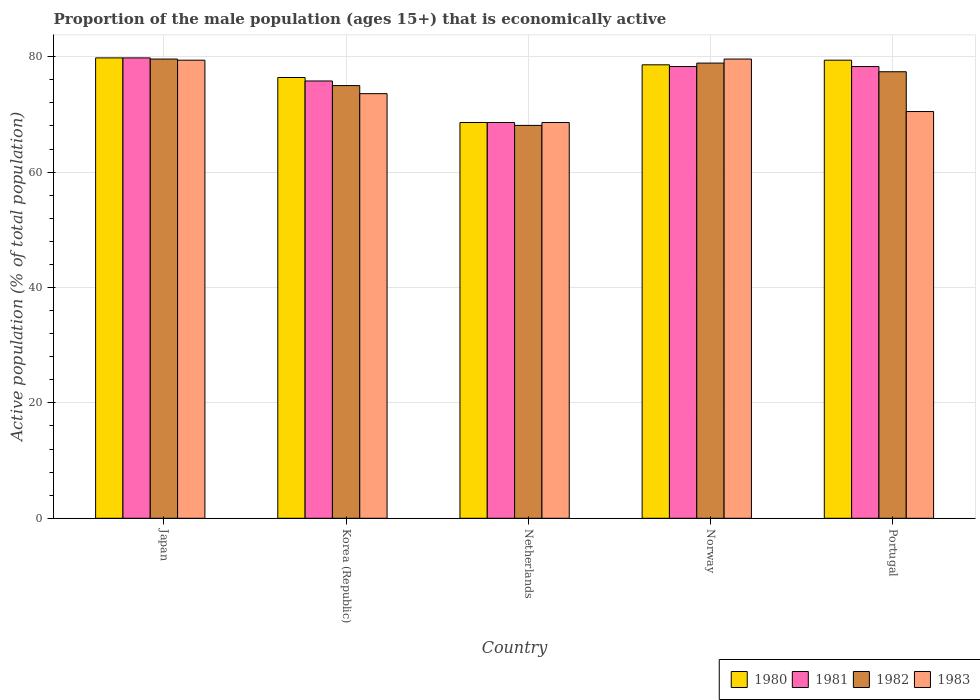How many different coloured bars are there?
Offer a very short reply. 4. Are the number of bars per tick equal to the number of legend labels?
Your answer should be compact. Yes. Are the number of bars on each tick of the X-axis equal?
Provide a short and direct response. Yes. How many bars are there on the 5th tick from the left?
Make the answer very short. 4. In how many cases, is the number of bars for a given country not equal to the number of legend labels?
Make the answer very short. 0. What is the proportion of the male population that is economically active in 1981 in Netherlands?
Your answer should be compact. 68.6. Across all countries, what is the maximum proportion of the male population that is economically active in 1983?
Your response must be concise. 79.6. Across all countries, what is the minimum proportion of the male population that is economically active in 1983?
Your answer should be very brief. 68.6. What is the total proportion of the male population that is economically active in 1983 in the graph?
Ensure brevity in your answer.  371.7. What is the difference between the proportion of the male population that is economically active in 1980 in Japan and that in Korea (Republic)?
Your answer should be very brief. 3.4. What is the difference between the proportion of the male population that is economically active in 1981 in Netherlands and the proportion of the male population that is economically active in 1983 in Portugal?
Provide a short and direct response. -1.9. What is the average proportion of the male population that is economically active in 1981 per country?
Your response must be concise. 76.16. What is the difference between the proportion of the male population that is economically active of/in 1983 and proportion of the male population that is economically active of/in 1981 in Portugal?
Your response must be concise. -7.8. In how many countries, is the proportion of the male population that is economically active in 1983 greater than 76 %?
Give a very brief answer. 2. What is the ratio of the proportion of the male population that is economically active in 1983 in Japan to that in Netherlands?
Give a very brief answer. 1.16. Is the proportion of the male population that is economically active in 1982 in Korea (Republic) less than that in Netherlands?
Make the answer very short. No. What is the difference between the highest and the second highest proportion of the male population that is economically active in 1980?
Make the answer very short. -0.8. What is the difference between the highest and the lowest proportion of the male population that is economically active in 1980?
Your answer should be very brief. 11.2. In how many countries, is the proportion of the male population that is economically active in 1981 greater than the average proportion of the male population that is economically active in 1981 taken over all countries?
Offer a terse response. 3. Is it the case that in every country, the sum of the proportion of the male population that is economically active in 1982 and proportion of the male population that is economically active in 1983 is greater than the sum of proportion of the male population that is economically active in 1980 and proportion of the male population that is economically active in 1981?
Offer a very short reply. No. What does the 4th bar from the right in Portugal represents?
Your answer should be compact. 1980. What is the difference between two consecutive major ticks on the Y-axis?
Make the answer very short. 20. Are the values on the major ticks of Y-axis written in scientific E-notation?
Keep it short and to the point. No. Does the graph contain any zero values?
Provide a short and direct response. No. Where does the legend appear in the graph?
Ensure brevity in your answer.  Bottom right. How many legend labels are there?
Make the answer very short. 4. What is the title of the graph?
Offer a terse response. Proportion of the male population (ages 15+) that is economically active. What is the label or title of the X-axis?
Make the answer very short. Country. What is the label or title of the Y-axis?
Give a very brief answer. Active population (% of total population). What is the Active population (% of total population) in 1980 in Japan?
Give a very brief answer. 79.8. What is the Active population (% of total population) in 1981 in Japan?
Your answer should be very brief. 79.8. What is the Active population (% of total population) of 1982 in Japan?
Your answer should be compact. 79.6. What is the Active population (% of total population) in 1983 in Japan?
Ensure brevity in your answer.  79.4. What is the Active population (% of total population) in 1980 in Korea (Republic)?
Your response must be concise. 76.4. What is the Active population (% of total population) of 1981 in Korea (Republic)?
Provide a succinct answer. 75.8. What is the Active population (% of total population) of 1983 in Korea (Republic)?
Offer a terse response. 73.6. What is the Active population (% of total population) of 1980 in Netherlands?
Provide a succinct answer. 68.6. What is the Active population (% of total population) in 1981 in Netherlands?
Your response must be concise. 68.6. What is the Active population (% of total population) in 1982 in Netherlands?
Provide a short and direct response. 68.1. What is the Active population (% of total population) in 1983 in Netherlands?
Your answer should be very brief. 68.6. What is the Active population (% of total population) of 1980 in Norway?
Make the answer very short. 78.6. What is the Active population (% of total population) in 1981 in Norway?
Offer a terse response. 78.3. What is the Active population (% of total population) in 1982 in Norway?
Ensure brevity in your answer.  78.9. What is the Active population (% of total population) of 1983 in Norway?
Ensure brevity in your answer.  79.6. What is the Active population (% of total population) in 1980 in Portugal?
Make the answer very short. 79.4. What is the Active population (% of total population) of 1981 in Portugal?
Your response must be concise. 78.3. What is the Active population (% of total population) of 1982 in Portugal?
Provide a succinct answer. 77.4. What is the Active population (% of total population) in 1983 in Portugal?
Provide a short and direct response. 70.5. Across all countries, what is the maximum Active population (% of total population) in 1980?
Offer a very short reply. 79.8. Across all countries, what is the maximum Active population (% of total population) in 1981?
Provide a succinct answer. 79.8. Across all countries, what is the maximum Active population (% of total population) in 1982?
Provide a short and direct response. 79.6. Across all countries, what is the maximum Active population (% of total population) of 1983?
Provide a short and direct response. 79.6. Across all countries, what is the minimum Active population (% of total population) of 1980?
Keep it short and to the point. 68.6. Across all countries, what is the minimum Active population (% of total population) in 1981?
Your response must be concise. 68.6. Across all countries, what is the minimum Active population (% of total population) of 1982?
Give a very brief answer. 68.1. Across all countries, what is the minimum Active population (% of total population) of 1983?
Your answer should be very brief. 68.6. What is the total Active population (% of total population) of 1980 in the graph?
Make the answer very short. 382.8. What is the total Active population (% of total population) in 1981 in the graph?
Offer a terse response. 380.8. What is the total Active population (% of total population) of 1982 in the graph?
Provide a succinct answer. 379. What is the total Active population (% of total population) in 1983 in the graph?
Make the answer very short. 371.7. What is the difference between the Active population (% of total population) of 1980 in Japan and that in Korea (Republic)?
Your answer should be very brief. 3.4. What is the difference between the Active population (% of total population) of 1981 in Japan and that in Korea (Republic)?
Your response must be concise. 4. What is the difference between the Active population (% of total population) in 1982 in Japan and that in Korea (Republic)?
Keep it short and to the point. 4.6. What is the difference between the Active population (% of total population) in 1983 in Japan and that in Korea (Republic)?
Offer a very short reply. 5.8. What is the difference between the Active population (% of total population) of 1980 in Japan and that in Netherlands?
Your answer should be very brief. 11.2. What is the difference between the Active population (% of total population) of 1982 in Japan and that in Netherlands?
Your answer should be very brief. 11.5. What is the difference between the Active population (% of total population) in 1983 in Japan and that in Netherlands?
Offer a terse response. 10.8. What is the difference between the Active population (% of total population) in 1980 in Japan and that in Norway?
Offer a very short reply. 1.2. What is the difference between the Active population (% of total population) of 1981 in Japan and that in Norway?
Keep it short and to the point. 1.5. What is the difference between the Active population (% of total population) in 1982 in Japan and that in Norway?
Your response must be concise. 0.7. What is the difference between the Active population (% of total population) of 1983 in Japan and that in Norway?
Make the answer very short. -0.2. What is the difference between the Active population (% of total population) of 1980 in Japan and that in Portugal?
Give a very brief answer. 0.4. What is the difference between the Active population (% of total population) in 1982 in Japan and that in Portugal?
Ensure brevity in your answer.  2.2. What is the difference between the Active population (% of total population) of 1983 in Japan and that in Portugal?
Offer a very short reply. 8.9. What is the difference between the Active population (% of total population) in 1982 in Korea (Republic) and that in Netherlands?
Keep it short and to the point. 6.9. What is the difference between the Active population (% of total population) in 1983 in Korea (Republic) and that in Netherlands?
Keep it short and to the point. 5. What is the difference between the Active population (% of total population) of 1982 in Korea (Republic) and that in Norway?
Keep it short and to the point. -3.9. What is the difference between the Active population (% of total population) in 1983 in Korea (Republic) and that in Norway?
Offer a very short reply. -6. What is the difference between the Active population (% of total population) in 1980 in Korea (Republic) and that in Portugal?
Offer a terse response. -3. What is the difference between the Active population (% of total population) in 1982 in Korea (Republic) and that in Portugal?
Your response must be concise. -2.4. What is the difference between the Active population (% of total population) of 1983 in Korea (Republic) and that in Portugal?
Ensure brevity in your answer.  3.1. What is the difference between the Active population (% of total population) of 1980 in Netherlands and that in Norway?
Provide a succinct answer. -10. What is the difference between the Active population (% of total population) in 1981 in Netherlands and that in Norway?
Your answer should be compact. -9.7. What is the difference between the Active population (% of total population) in 1983 in Netherlands and that in Norway?
Provide a short and direct response. -11. What is the difference between the Active population (% of total population) of 1981 in Netherlands and that in Portugal?
Offer a terse response. -9.7. What is the difference between the Active population (% of total population) of 1983 in Netherlands and that in Portugal?
Offer a very short reply. -1.9. What is the difference between the Active population (% of total population) of 1980 in Norway and that in Portugal?
Your response must be concise. -0.8. What is the difference between the Active population (% of total population) of 1982 in Norway and that in Portugal?
Keep it short and to the point. 1.5. What is the difference between the Active population (% of total population) in 1980 in Japan and the Active population (% of total population) in 1982 in Korea (Republic)?
Your response must be concise. 4.8. What is the difference between the Active population (% of total population) of 1981 in Japan and the Active population (% of total population) of 1982 in Korea (Republic)?
Make the answer very short. 4.8. What is the difference between the Active population (% of total population) in 1982 in Japan and the Active population (% of total population) in 1983 in Korea (Republic)?
Keep it short and to the point. 6. What is the difference between the Active population (% of total population) of 1980 in Japan and the Active population (% of total population) of 1983 in Netherlands?
Make the answer very short. 11.2. What is the difference between the Active population (% of total population) in 1981 in Japan and the Active population (% of total population) in 1983 in Netherlands?
Offer a very short reply. 11.2. What is the difference between the Active population (% of total population) in 1980 in Japan and the Active population (% of total population) in 1981 in Norway?
Ensure brevity in your answer.  1.5. What is the difference between the Active population (% of total population) of 1981 in Japan and the Active population (% of total population) of 1982 in Norway?
Ensure brevity in your answer.  0.9. What is the difference between the Active population (% of total population) of 1982 in Japan and the Active population (% of total population) of 1983 in Norway?
Offer a very short reply. 0. What is the difference between the Active population (% of total population) of 1980 in Japan and the Active population (% of total population) of 1982 in Portugal?
Offer a very short reply. 2.4. What is the difference between the Active population (% of total population) of 1981 in Japan and the Active population (% of total population) of 1982 in Portugal?
Your response must be concise. 2.4. What is the difference between the Active population (% of total population) of 1980 in Korea (Republic) and the Active population (% of total population) of 1981 in Netherlands?
Keep it short and to the point. 7.8. What is the difference between the Active population (% of total population) in 1981 in Korea (Republic) and the Active population (% of total population) in 1982 in Netherlands?
Offer a terse response. 7.7. What is the difference between the Active population (% of total population) in 1980 in Korea (Republic) and the Active population (% of total population) in 1981 in Norway?
Offer a terse response. -1.9. What is the difference between the Active population (% of total population) in 1981 in Korea (Republic) and the Active population (% of total population) in 1982 in Norway?
Keep it short and to the point. -3.1. What is the difference between the Active population (% of total population) of 1982 in Korea (Republic) and the Active population (% of total population) of 1983 in Norway?
Your answer should be compact. -4.6. What is the difference between the Active population (% of total population) in 1980 in Korea (Republic) and the Active population (% of total population) in 1981 in Portugal?
Your answer should be compact. -1.9. What is the difference between the Active population (% of total population) of 1980 in Korea (Republic) and the Active population (% of total population) of 1982 in Portugal?
Provide a succinct answer. -1. What is the difference between the Active population (% of total population) of 1980 in Korea (Republic) and the Active population (% of total population) of 1983 in Portugal?
Offer a terse response. 5.9. What is the difference between the Active population (% of total population) in 1981 in Korea (Republic) and the Active population (% of total population) in 1982 in Portugal?
Make the answer very short. -1.6. What is the difference between the Active population (% of total population) of 1981 in Korea (Republic) and the Active population (% of total population) of 1983 in Portugal?
Provide a short and direct response. 5.3. What is the difference between the Active population (% of total population) in 1982 in Korea (Republic) and the Active population (% of total population) in 1983 in Portugal?
Your answer should be very brief. 4.5. What is the difference between the Active population (% of total population) in 1980 in Netherlands and the Active population (% of total population) in 1981 in Norway?
Make the answer very short. -9.7. What is the difference between the Active population (% of total population) in 1980 in Netherlands and the Active population (% of total population) in 1983 in Norway?
Your response must be concise. -11. What is the difference between the Active population (% of total population) in 1981 in Netherlands and the Active population (% of total population) in 1982 in Norway?
Offer a terse response. -10.3. What is the difference between the Active population (% of total population) in 1981 in Netherlands and the Active population (% of total population) in 1983 in Norway?
Keep it short and to the point. -11. What is the difference between the Active population (% of total population) in 1982 in Netherlands and the Active population (% of total population) in 1983 in Norway?
Keep it short and to the point. -11.5. What is the difference between the Active population (% of total population) of 1981 in Netherlands and the Active population (% of total population) of 1982 in Portugal?
Provide a short and direct response. -8.8. What is the difference between the Active population (% of total population) in 1981 in Netherlands and the Active population (% of total population) in 1983 in Portugal?
Offer a terse response. -1.9. What is the difference between the Active population (% of total population) of 1982 in Netherlands and the Active population (% of total population) of 1983 in Portugal?
Provide a short and direct response. -2.4. What is the difference between the Active population (% of total population) in 1980 in Norway and the Active population (% of total population) in 1983 in Portugal?
Provide a succinct answer. 8.1. What is the difference between the Active population (% of total population) in 1981 in Norway and the Active population (% of total population) in 1982 in Portugal?
Provide a short and direct response. 0.9. What is the average Active population (% of total population) in 1980 per country?
Make the answer very short. 76.56. What is the average Active population (% of total population) in 1981 per country?
Keep it short and to the point. 76.16. What is the average Active population (% of total population) of 1982 per country?
Offer a very short reply. 75.8. What is the average Active population (% of total population) in 1983 per country?
Your answer should be very brief. 74.34. What is the difference between the Active population (% of total population) of 1980 and Active population (% of total population) of 1981 in Japan?
Offer a terse response. 0. What is the difference between the Active population (% of total population) of 1980 and Active population (% of total population) of 1982 in Japan?
Give a very brief answer. 0.2. What is the difference between the Active population (% of total population) in 1981 and Active population (% of total population) in 1983 in Japan?
Your answer should be very brief. 0.4. What is the difference between the Active population (% of total population) of 1982 and Active population (% of total population) of 1983 in Japan?
Make the answer very short. 0.2. What is the difference between the Active population (% of total population) in 1980 and Active population (% of total population) in 1981 in Korea (Republic)?
Keep it short and to the point. 0.6. What is the difference between the Active population (% of total population) of 1980 and Active population (% of total population) of 1983 in Korea (Republic)?
Your response must be concise. 2.8. What is the difference between the Active population (% of total population) in 1981 and Active population (% of total population) in 1982 in Korea (Republic)?
Provide a short and direct response. 0.8. What is the difference between the Active population (% of total population) of 1980 and Active population (% of total population) of 1981 in Netherlands?
Keep it short and to the point. 0. What is the difference between the Active population (% of total population) of 1980 and Active population (% of total population) of 1983 in Netherlands?
Your response must be concise. 0. What is the difference between the Active population (% of total population) in 1981 and Active population (% of total population) in 1982 in Netherlands?
Your answer should be compact. 0.5. What is the difference between the Active population (% of total population) of 1981 and Active population (% of total population) of 1983 in Netherlands?
Offer a terse response. 0. What is the difference between the Active population (% of total population) in 1980 and Active population (% of total population) in 1983 in Norway?
Your answer should be compact. -1. What is the difference between the Active population (% of total population) in 1981 and Active population (% of total population) in 1982 in Norway?
Your response must be concise. -0.6. What is the difference between the Active population (% of total population) of 1982 and Active population (% of total population) of 1983 in Norway?
Provide a short and direct response. -0.7. What is the difference between the Active population (% of total population) of 1981 and Active population (% of total population) of 1982 in Portugal?
Offer a very short reply. 0.9. What is the difference between the Active population (% of total population) of 1981 and Active population (% of total population) of 1983 in Portugal?
Provide a short and direct response. 7.8. What is the difference between the Active population (% of total population) in 1982 and Active population (% of total population) in 1983 in Portugal?
Your response must be concise. 6.9. What is the ratio of the Active population (% of total population) in 1980 in Japan to that in Korea (Republic)?
Offer a terse response. 1.04. What is the ratio of the Active population (% of total population) of 1981 in Japan to that in Korea (Republic)?
Your answer should be very brief. 1.05. What is the ratio of the Active population (% of total population) in 1982 in Japan to that in Korea (Republic)?
Give a very brief answer. 1.06. What is the ratio of the Active population (% of total population) of 1983 in Japan to that in Korea (Republic)?
Provide a short and direct response. 1.08. What is the ratio of the Active population (% of total population) of 1980 in Japan to that in Netherlands?
Give a very brief answer. 1.16. What is the ratio of the Active population (% of total population) of 1981 in Japan to that in Netherlands?
Your answer should be very brief. 1.16. What is the ratio of the Active population (% of total population) in 1982 in Japan to that in Netherlands?
Give a very brief answer. 1.17. What is the ratio of the Active population (% of total population) in 1983 in Japan to that in Netherlands?
Provide a succinct answer. 1.16. What is the ratio of the Active population (% of total population) of 1980 in Japan to that in Norway?
Provide a succinct answer. 1.02. What is the ratio of the Active population (% of total population) of 1981 in Japan to that in Norway?
Give a very brief answer. 1.02. What is the ratio of the Active population (% of total population) of 1982 in Japan to that in Norway?
Your response must be concise. 1.01. What is the ratio of the Active population (% of total population) in 1983 in Japan to that in Norway?
Make the answer very short. 1. What is the ratio of the Active population (% of total population) in 1980 in Japan to that in Portugal?
Your answer should be very brief. 1. What is the ratio of the Active population (% of total population) in 1981 in Japan to that in Portugal?
Offer a terse response. 1.02. What is the ratio of the Active population (% of total population) in 1982 in Japan to that in Portugal?
Your answer should be compact. 1.03. What is the ratio of the Active population (% of total population) of 1983 in Japan to that in Portugal?
Keep it short and to the point. 1.13. What is the ratio of the Active population (% of total population) of 1980 in Korea (Republic) to that in Netherlands?
Your response must be concise. 1.11. What is the ratio of the Active population (% of total population) in 1981 in Korea (Republic) to that in Netherlands?
Make the answer very short. 1.1. What is the ratio of the Active population (% of total population) of 1982 in Korea (Republic) to that in Netherlands?
Offer a very short reply. 1.1. What is the ratio of the Active population (% of total population) of 1983 in Korea (Republic) to that in Netherlands?
Your response must be concise. 1.07. What is the ratio of the Active population (% of total population) of 1981 in Korea (Republic) to that in Norway?
Your answer should be compact. 0.97. What is the ratio of the Active population (% of total population) in 1982 in Korea (Republic) to that in Norway?
Keep it short and to the point. 0.95. What is the ratio of the Active population (% of total population) of 1983 in Korea (Republic) to that in Norway?
Provide a short and direct response. 0.92. What is the ratio of the Active population (% of total population) in 1980 in Korea (Republic) to that in Portugal?
Make the answer very short. 0.96. What is the ratio of the Active population (% of total population) of 1981 in Korea (Republic) to that in Portugal?
Ensure brevity in your answer.  0.97. What is the ratio of the Active population (% of total population) in 1982 in Korea (Republic) to that in Portugal?
Provide a succinct answer. 0.97. What is the ratio of the Active population (% of total population) of 1983 in Korea (Republic) to that in Portugal?
Provide a short and direct response. 1.04. What is the ratio of the Active population (% of total population) in 1980 in Netherlands to that in Norway?
Make the answer very short. 0.87. What is the ratio of the Active population (% of total population) in 1981 in Netherlands to that in Norway?
Offer a very short reply. 0.88. What is the ratio of the Active population (% of total population) of 1982 in Netherlands to that in Norway?
Your response must be concise. 0.86. What is the ratio of the Active population (% of total population) of 1983 in Netherlands to that in Norway?
Offer a very short reply. 0.86. What is the ratio of the Active population (% of total population) in 1980 in Netherlands to that in Portugal?
Provide a short and direct response. 0.86. What is the ratio of the Active population (% of total population) of 1981 in Netherlands to that in Portugal?
Offer a very short reply. 0.88. What is the ratio of the Active population (% of total population) in 1982 in Netherlands to that in Portugal?
Provide a short and direct response. 0.88. What is the ratio of the Active population (% of total population) of 1982 in Norway to that in Portugal?
Your answer should be compact. 1.02. What is the ratio of the Active population (% of total population) of 1983 in Norway to that in Portugal?
Ensure brevity in your answer.  1.13. What is the difference between the highest and the second highest Active population (% of total population) of 1980?
Your response must be concise. 0.4. What is the difference between the highest and the second highest Active population (% of total population) in 1982?
Ensure brevity in your answer.  0.7. What is the difference between the highest and the lowest Active population (% of total population) in 1981?
Your answer should be very brief. 11.2. What is the difference between the highest and the lowest Active population (% of total population) of 1982?
Ensure brevity in your answer.  11.5. What is the difference between the highest and the lowest Active population (% of total population) in 1983?
Provide a short and direct response. 11. 